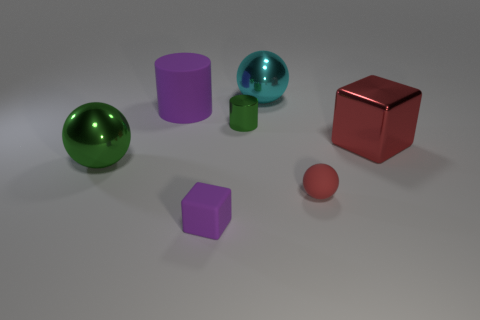What is the shape of the big cyan thing that is the same material as the large green ball?
Provide a succinct answer. Sphere. Is the shape of the red thing that is to the right of the red rubber sphere the same as  the big green shiny object?
Your answer should be compact. No. How big is the rubber thing on the right side of the purple matte thing in front of the green shiny ball?
Ensure brevity in your answer.  Small. There is a small cylinder that is made of the same material as the large red cube; what is its color?
Give a very brief answer. Green. What number of rubber balls are the same size as the purple matte cylinder?
Offer a very short reply. 0. How many red things are tiny metal cylinders or large metal things?
Your answer should be very brief. 1. How many things are blue metallic cylinders or large balls in front of the red cube?
Provide a succinct answer. 1. There is a green thing behind the shiny cube; what material is it?
Provide a succinct answer. Metal. What shape is the green thing that is the same size as the red sphere?
Offer a terse response. Cylinder. Is there another purple rubber thing that has the same shape as the big purple rubber thing?
Make the answer very short. No. 